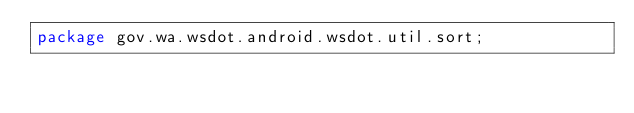<code> <loc_0><loc_0><loc_500><loc_500><_Java_>package gov.wa.wsdot.android.wsdot.util.sort;
</code> 